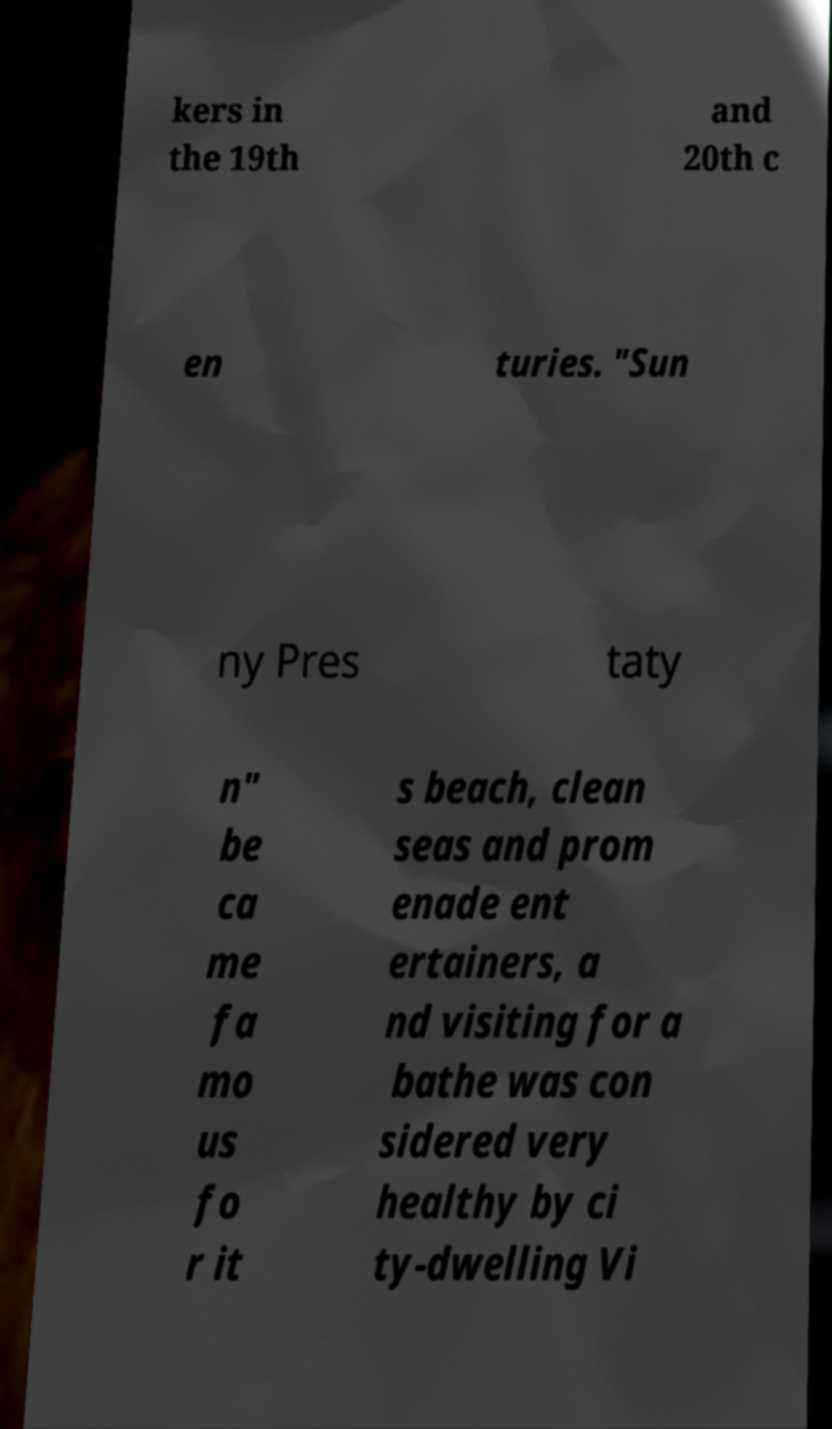There's text embedded in this image that I need extracted. Can you transcribe it verbatim? kers in the 19th and 20th c en turies. "Sun ny Pres taty n" be ca me fa mo us fo r it s beach, clean seas and prom enade ent ertainers, a nd visiting for a bathe was con sidered very healthy by ci ty-dwelling Vi 